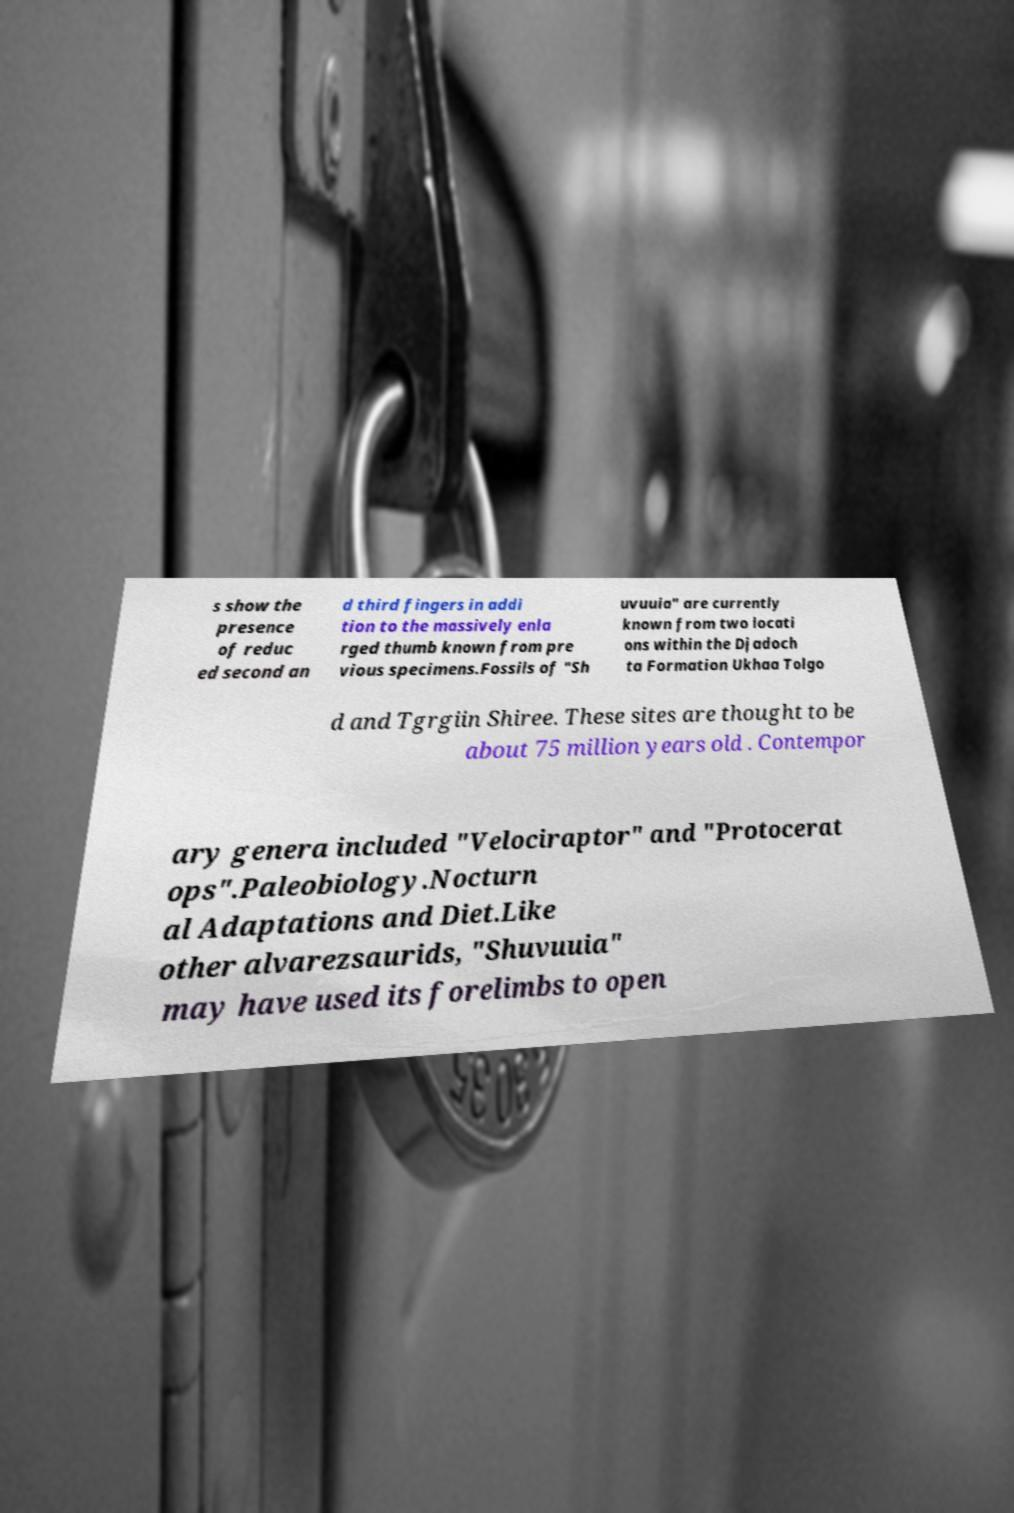There's text embedded in this image that I need extracted. Can you transcribe it verbatim? s show the presence of reduc ed second an d third fingers in addi tion to the massively enla rged thumb known from pre vious specimens.Fossils of "Sh uvuuia" are currently known from two locati ons within the Djadoch ta Formation Ukhaa Tolgo d and Tgrgiin Shiree. These sites are thought to be about 75 million years old . Contempor ary genera included "Velociraptor" and "Protocerat ops".Paleobiology.Nocturn al Adaptations and Diet.Like other alvarezsaurids, "Shuvuuia" may have used its forelimbs to open 